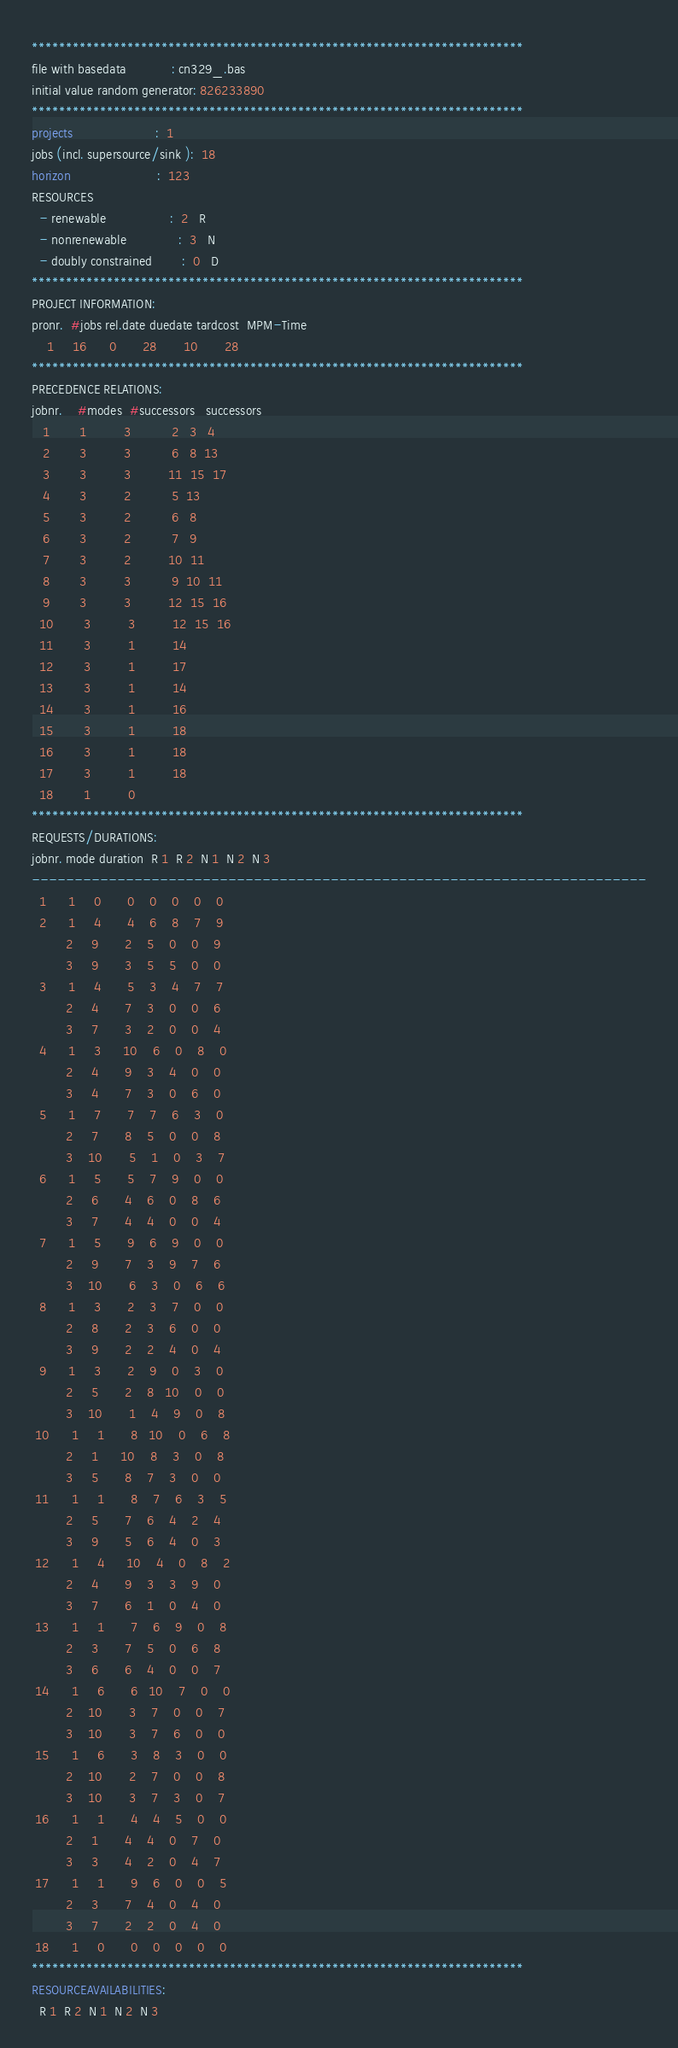Convert code to text. <code><loc_0><loc_0><loc_500><loc_500><_ObjectiveC_>************************************************************************
file with basedata            : cn329_.bas
initial value random generator: 826233890
************************************************************************
projects                      :  1
jobs (incl. supersource/sink ):  18
horizon                       :  123
RESOURCES
  - renewable                 :  2   R
  - nonrenewable              :  3   N
  - doubly constrained        :  0   D
************************************************************************
PROJECT INFORMATION:
pronr.  #jobs rel.date duedate tardcost  MPM-Time
    1     16      0       28       10       28
************************************************************************
PRECEDENCE RELATIONS:
jobnr.    #modes  #successors   successors
   1        1          3           2   3   4
   2        3          3           6   8  13
   3        3          3          11  15  17
   4        3          2           5  13
   5        3          2           6   8
   6        3          2           7   9
   7        3          2          10  11
   8        3          3           9  10  11
   9        3          3          12  15  16
  10        3          3          12  15  16
  11        3          1          14
  12        3          1          17
  13        3          1          14
  14        3          1          16
  15        3          1          18
  16        3          1          18
  17        3          1          18
  18        1          0        
************************************************************************
REQUESTS/DURATIONS:
jobnr. mode duration  R 1  R 2  N 1  N 2  N 3
------------------------------------------------------------------------
  1      1     0       0    0    0    0    0
  2      1     4       4    6    8    7    9
         2     9       2    5    0    0    9
         3     9       3    5    5    0    0
  3      1     4       5    3    4    7    7
         2     4       7    3    0    0    6
         3     7       3    2    0    0    4
  4      1     3      10    6    0    8    0
         2     4       9    3    4    0    0
         3     4       7    3    0    6    0
  5      1     7       7    7    6    3    0
         2     7       8    5    0    0    8
         3    10       5    1    0    3    7
  6      1     5       5    7    9    0    0
         2     6       4    6    0    8    6
         3     7       4    4    0    0    4
  7      1     5       9    6    9    0    0
         2     9       7    3    9    7    6
         3    10       6    3    0    6    6
  8      1     3       2    3    7    0    0
         2     8       2    3    6    0    0
         3     9       2    2    4    0    4
  9      1     3       2    9    0    3    0
         2     5       2    8   10    0    0
         3    10       1    4    9    0    8
 10      1     1       8   10    0    6    8
         2     1      10    8    3    0    8
         3     5       8    7    3    0    0
 11      1     1       8    7    6    3    5
         2     5       7    6    4    2    4
         3     9       5    6    4    0    3
 12      1     4      10    4    0    8    2
         2     4       9    3    3    9    0
         3     7       6    1    0    4    0
 13      1     1       7    6    9    0    8
         2     3       7    5    0    6    8
         3     6       6    4    0    0    7
 14      1     6       6   10    7    0    0
         2    10       3    7    0    0    7
         3    10       3    7    6    0    0
 15      1     6       3    8    3    0    0
         2    10       2    7    0    0    8
         3    10       3    7    3    0    7
 16      1     1       4    4    5    0    0
         2     1       4    4    0    7    0
         3     3       4    2    0    4    7
 17      1     1       9    6    0    0    5
         2     3       7    4    0    4    0
         3     7       2    2    0    4    0
 18      1     0       0    0    0    0    0
************************************************************************
RESOURCEAVAILABILITIES:
  R 1  R 2  N 1  N 2  N 3</code> 